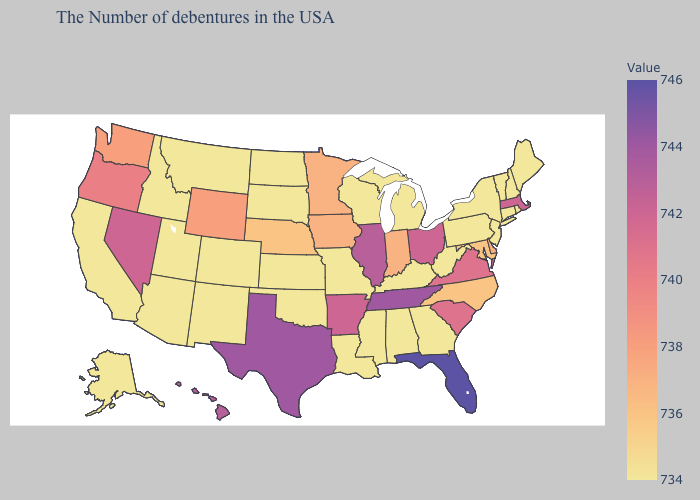Is the legend a continuous bar?
Give a very brief answer. Yes. Which states have the highest value in the USA?
Write a very short answer. Florida. Does Kansas have the highest value in the MidWest?
Give a very brief answer. No. 